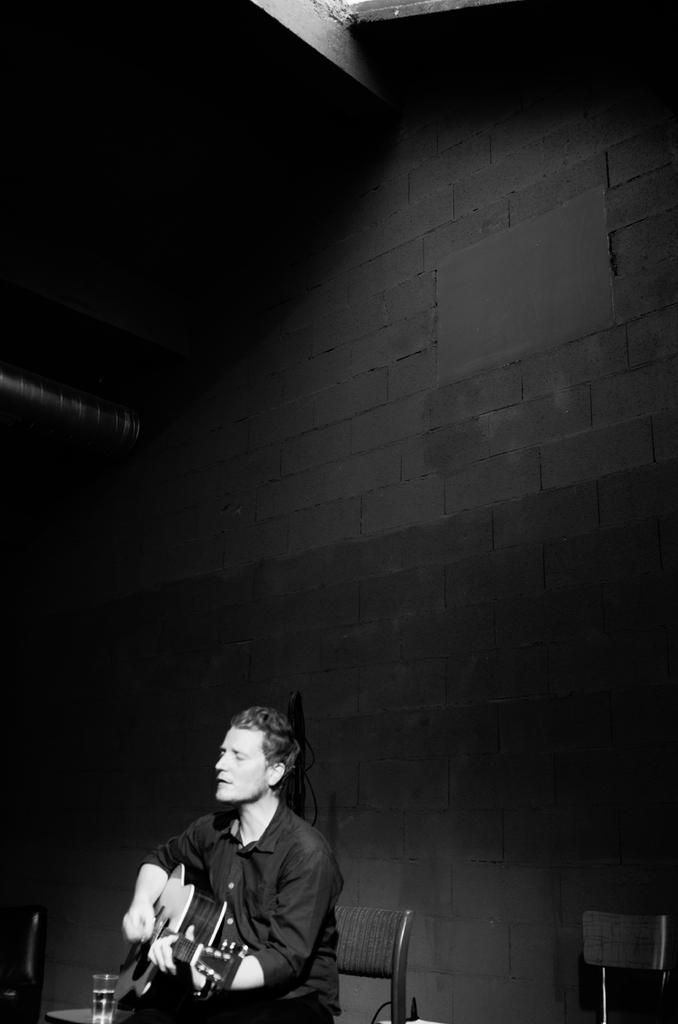What is the man in the image doing? The man is sitting on a chair and playing the guitar. What object is on the table in the image? There is a water bottle on a table in the image. What type of lettuce is being served for lunch in the image? There is no lettuce or lunch present in the image; it only features a man playing the guitar and a water bottle on a table. 